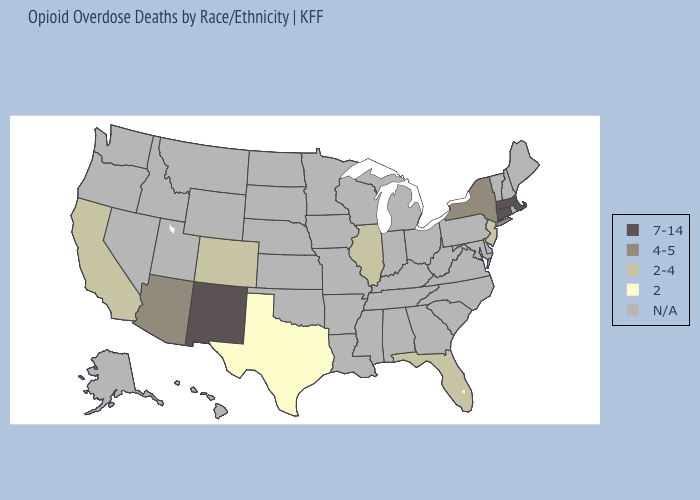Does Florida have the lowest value in the South?
Be succinct. No. What is the value of Utah?
Concise answer only. N/A. Does New Jersey have the highest value in the Northeast?
Keep it brief. No. Which states have the lowest value in the USA?
Concise answer only. Texas. What is the lowest value in the West?
Write a very short answer. 2-4. What is the value of West Virginia?
Give a very brief answer. N/A. What is the highest value in the USA?
Quick response, please. 7-14. What is the highest value in the USA?
Quick response, please. 7-14. What is the value of Maryland?
Be succinct. N/A. What is the highest value in states that border Missouri?
Be succinct. 2-4. What is the highest value in the West ?
Answer briefly. 7-14. Name the states that have a value in the range 4-5?
Keep it brief. Arizona, New York. What is the highest value in the MidWest ?
Concise answer only. 2-4. 